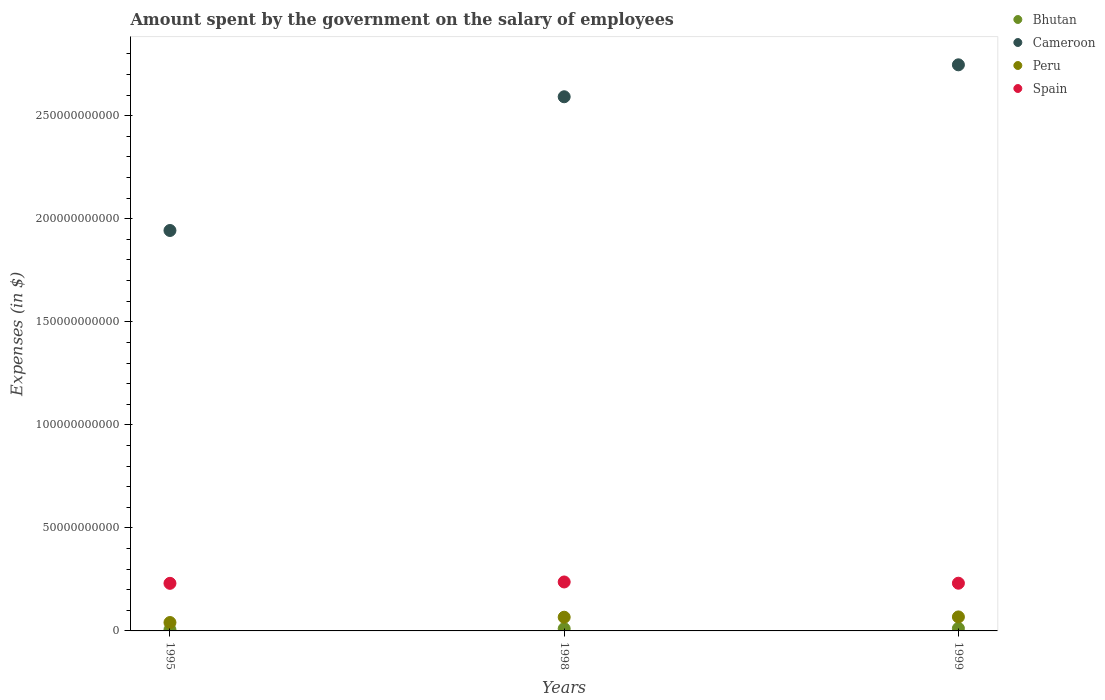Is the number of dotlines equal to the number of legend labels?
Provide a short and direct response. Yes. What is the amount spent on the salary of employees by the government in Cameroon in 1999?
Keep it short and to the point. 2.75e+11. Across all years, what is the maximum amount spent on the salary of employees by the government in Spain?
Ensure brevity in your answer.  2.38e+1. Across all years, what is the minimum amount spent on the salary of employees by the government in Cameroon?
Provide a succinct answer. 1.94e+11. In which year was the amount spent on the salary of employees by the government in Peru maximum?
Provide a succinct answer. 1999. What is the total amount spent on the salary of employees by the government in Bhutan in the graph?
Offer a very short reply. 2.93e+09. What is the difference between the amount spent on the salary of employees by the government in Cameroon in 1995 and that in 1999?
Provide a succinct answer. -8.04e+1. What is the difference between the amount spent on the salary of employees by the government in Peru in 1995 and the amount spent on the salary of employees by the government in Bhutan in 1999?
Provide a short and direct response. 2.85e+09. What is the average amount spent on the salary of employees by the government in Cameroon per year?
Make the answer very short. 2.43e+11. In the year 1998, what is the difference between the amount spent on the salary of employees by the government in Spain and amount spent on the salary of employees by the government in Cameroon?
Provide a short and direct response. -2.35e+11. What is the ratio of the amount spent on the salary of employees by the government in Cameroon in 1995 to that in 1998?
Offer a terse response. 0.75. What is the difference between the highest and the second highest amount spent on the salary of employees by the government in Spain?
Offer a very short reply. 6.02e+08. What is the difference between the highest and the lowest amount spent on the salary of employees by the government in Cameroon?
Offer a terse response. 8.04e+1. In how many years, is the amount spent on the salary of employees by the government in Spain greater than the average amount spent on the salary of employees by the government in Spain taken over all years?
Give a very brief answer. 1. Is the sum of the amount spent on the salary of employees by the government in Cameroon in 1998 and 1999 greater than the maximum amount spent on the salary of employees by the government in Bhutan across all years?
Provide a succinct answer. Yes. Does the amount spent on the salary of employees by the government in Bhutan monotonically increase over the years?
Keep it short and to the point. Yes. Is the amount spent on the salary of employees by the government in Peru strictly greater than the amount spent on the salary of employees by the government in Spain over the years?
Give a very brief answer. No. Is the amount spent on the salary of employees by the government in Bhutan strictly less than the amount spent on the salary of employees by the government in Cameroon over the years?
Offer a very short reply. Yes. How many dotlines are there?
Your answer should be very brief. 4. How many years are there in the graph?
Provide a succinct answer. 3. What is the difference between two consecutive major ticks on the Y-axis?
Offer a terse response. 5.00e+1. Does the graph contain any zero values?
Offer a very short reply. No. Does the graph contain grids?
Your answer should be very brief. No. Where does the legend appear in the graph?
Give a very brief answer. Top right. How many legend labels are there?
Ensure brevity in your answer.  4. What is the title of the graph?
Make the answer very short. Amount spent by the government on the salary of employees. What is the label or title of the Y-axis?
Provide a succinct answer. Expenses (in $). What is the Expenses (in $) in Bhutan in 1995?
Offer a terse response. 6.14e+08. What is the Expenses (in $) in Cameroon in 1995?
Offer a very short reply. 1.94e+11. What is the Expenses (in $) in Peru in 1995?
Your response must be concise. 4.08e+09. What is the Expenses (in $) of Spain in 1995?
Offer a very short reply. 2.31e+1. What is the Expenses (in $) in Bhutan in 1998?
Your answer should be very brief. 1.08e+09. What is the Expenses (in $) of Cameroon in 1998?
Your response must be concise. 2.59e+11. What is the Expenses (in $) in Peru in 1998?
Keep it short and to the point. 6.65e+09. What is the Expenses (in $) of Spain in 1998?
Offer a terse response. 2.38e+1. What is the Expenses (in $) of Bhutan in 1999?
Offer a terse response. 1.23e+09. What is the Expenses (in $) of Cameroon in 1999?
Keep it short and to the point. 2.75e+11. What is the Expenses (in $) of Peru in 1999?
Your answer should be very brief. 6.79e+09. What is the Expenses (in $) of Spain in 1999?
Your response must be concise. 2.32e+1. Across all years, what is the maximum Expenses (in $) of Bhutan?
Make the answer very short. 1.23e+09. Across all years, what is the maximum Expenses (in $) in Cameroon?
Ensure brevity in your answer.  2.75e+11. Across all years, what is the maximum Expenses (in $) of Peru?
Keep it short and to the point. 6.79e+09. Across all years, what is the maximum Expenses (in $) in Spain?
Your answer should be compact. 2.38e+1. Across all years, what is the minimum Expenses (in $) in Bhutan?
Give a very brief answer. 6.14e+08. Across all years, what is the minimum Expenses (in $) of Cameroon?
Ensure brevity in your answer.  1.94e+11. Across all years, what is the minimum Expenses (in $) of Peru?
Ensure brevity in your answer.  4.08e+09. Across all years, what is the minimum Expenses (in $) of Spain?
Offer a very short reply. 2.31e+1. What is the total Expenses (in $) of Bhutan in the graph?
Provide a succinct answer. 2.93e+09. What is the total Expenses (in $) of Cameroon in the graph?
Provide a short and direct response. 7.28e+11. What is the total Expenses (in $) of Peru in the graph?
Offer a very short reply. 1.75e+1. What is the total Expenses (in $) of Spain in the graph?
Offer a terse response. 7.00e+1. What is the difference between the Expenses (in $) of Bhutan in 1995 and that in 1998?
Offer a terse response. -4.71e+08. What is the difference between the Expenses (in $) of Cameroon in 1995 and that in 1998?
Offer a very short reply. -6.49e+1. What is the difference between the Expenses (in $) in Peru in 1995 and that in 1998?
Offer a very short reply. -2.57e+09. What is the difference between the Expenses (in $) of Spain in 1995 and that in 1998?
Offer a terse response. -6.63e+08. What is the difference between the Expenses (in $) of Bhutan in 1995 and that in 1999?
Your answer should be very brief. -6.16e+08. What is the difference between the Expenses (in $) of Cameroon in 1995 and that in 1999?
Make the answer very short. -8.04e+1. What is the difference between the Expenses (in $) in Peru in 1995 and that in 1999?
Keep it short and to the point. -2.72e+09. What is the difference between the Expenses (in $) of Spain in 1995 and that in 1999?
Give a very brief answer. -6.10e+07. What is the difference between the Expenses (in $) of Bhutan in 1998 and that in 1999?
Your answer should be very brief. -1.44e+08. What is the difference between the Expenses (in $) of Cameroon in 1998 and that in 1999?
Ensure brevity in your answer.  -1.55e+1. What is the difference between the Expenses (in $) in Peru in 1998 and that in 1999?
Your response must be concise. -1.46e+08. What is the difference between the Expenses (in $) of Spain in 1998 and that in 1999?
Offer a very short reply. 6.02e+08. What is the difference between the Expenses (in $) in Bhutan in 1995 and the Expenses (in $) in Cameroon in 1998?
Ensure brevity in your answer.  -2.59e+11. What is the difference between the Expenses (in $) in Bhutan in 1995 and the Expenses (in $) in Peru in 1998?
Provide a short and direct response. -6.03e+09. What is the difference between the Expenses (in $) in Bhutan in 1995 and the Expenses (in $) in Spain in 1998?
Give a very brief answer. -2.31e+1. What is the difference between the Expenses (in $) of Cameroon in 1995 and the Expenses (in $) of Peru in 1998?
Your answer should be very brief. 1.88e+11. What is the difference between the Expenses (in $) in Cameroon in 1995 and the Expenses (in $) in Spain in 1998?
Provide a succinct answer. 1.71e+11. What is the difference between the Expenses (in $) in Peru in 1995 and the Expenses (in $) in Spain in 1998?
Your answer should be compact. -1.97e+1. What is the difference between the Expenses (in $) of Bhutan in 1995 and the Expenses (in $) of Cameroon in 1999?
Your answer should be compact. -2.74e+11. What is the difference between the Expenses (in $) of Bhutan in 1995 and the Expenses (in $) of Peru in 1999?
Offer a terse response. -6.18e+09. What is the difference between the Expenses (in $) of Bhutan in 1995 and the Expenses (in $) of Spain in 1999?
Give a very brief answer. -2.25e+1. What is the difference between the Expenses (in $) of Cameroon in 1995 and the Expenses (in $) of Peru in 1999?
Ensure brevity in your answer.  1.88e+11. What is the difference between the Expenses (in $) of Cameroon in 1995 and the Expenses (in $) of Spain in 1999?
Your response must be concise. 1.71e+11. What is the difference between the Expenses (in $) of Peru in 1995 and the Expenses (in $) of Spain in 1999?
Your answer should be compact. -1.91e+1. What is the difference between the Expenses (in $) of Bhutan in 1998 and the Expenses (in $) of Cameroon in 1999?
Ensure brevity in your answer.  -2.74e+11. What is the difference between the Expenses (in $) of Bhutan in 1998 and the Expenses (in $) of Peru in 1999?
Offer a terse response. -5.71e+09. What is the difference between the Expenses (in $) in Bhutan in 1998 and the Expenses (in $) in Spain in 1999?
Give a very brief answer. -2.21e+1. What is the difference between the Expenses (in $) of Cameroon in 1998 and the Expenses (in $) of Peru in 1999?
Your answer should be very brief. 2.52e+11. What is the difference between the Expenses (in $) of Cameroon in 1998 and the Expenses (in $) of Spain in 1999?
Offer a terse response. 2.36e+11. What is the difference between the Expenses (in $) in Peru in 1998 and the Expenses (in $) in Spain in 1999?
Offer a very short reply. -1.65e+1. What is the average Expenses (in $) in Bhutan per year?
Your response must be concise. 9.76e+08. What is the average Expenses (in $) of Cameroon per year?
Make the answer very short. 2.43e+11. What is the average Expenses (in $) in Peru per year?
Keep it short and to the point. 5.84e+09. What is the average Expenses (in $) in Spain per year?
Ensure brevity in your answer.  2.33e+1. In the year 1995, what is the difference between the Expenses (in $) of Bhutan and Expenses (in $) of Cameroon?
Keep it short and to the point. -1.94e+11. In the year 1995, what is the difference between the Expenses (in $) of Bhutan and Expenses (in $) of Peru?
Provide a succinct answer. -3.46e+09. In the year 1995, what is the difference between the Expenses (in $) of Bhutan and Expenses (in $) of Spain?
Keep it short and to the point. -2.25e+1. In the year 1995, what is the difference between the Expenses (in $) in Cameroon and Expenses (in $) in Peru?
Keep it short and to the point. 1.90e+11. In the year 1995, what is the difference between the Expenses (in $) of Cameroon and Expenses (in $) of Spain?
Ensure brevity in your answer.  1.71e+11. In the year 1995, what is the difference between the Expenses (in $) in Peru and Expenses (in $) in Spain?
Offer a very short reply. -1.90e+1. In the year 1998, what is the difference between the Expenses (in $) in Bhutan and Expenses (in $) in Cameroon?
Give a very brief answer. -2.58e+11. In the year 1998, what is the difference between the Expenses (in $) in Bhutan and Expenses (in $) in Peru?
Give a very brief answer. -5.56e+09. In the year 1998, what is the difference between the Expenses (in $) of Bhutan and Expenses (in $) of Spain?
Offer a very short reply. -2.27e+1. In the year 1998, what is the difference between the Expenses (in $) of Cameroon and Expenses (in $) of Peru?
Make the answer very short. 2.53e+11. In the year 1998, what is the difference between the Expenses (in $) in Cameroon and Expenses (in $) in Spain?
Provide a short and direct response. 2.35e+11. In the year 1998, what is the difference between the Expenses (in $) of Peru and Expenses (in $) of Spain?
Your answer should be compact. -1.71e+1. In the year 1999, what is the difference between the Expenses (in $) in Bhutan and Expenses (in $) in Cameroon?
Keep it short and to the point. -2.73e+11. In the year 1999, what is the difference between the Expenses (in $) of Bhutan and Expenses (in $) of Peru?
Keep it short and to the point. -5.56e+09. In the year 1999, what is the difference between the Expenses (in $) of Bhutan and Expenses (in $) of Spain?
Offer a terse response. -2.19e+1. In the year 1999, what is the difference between the Expenses (in $) of Cameroon and Expenses (in $) of Peru?
Offer a very short reply. 2.68e+11. In the year 1999, what is the difference between the Expenses (in $) of Cameroon and Expenses (in $) of Spain?
Make the answer very short. 2.52e+11. In the year 1999, what is the difference between the Expenses (in $) of Peru and Expenses (in $) of Spain?
Offer a terse response. -1.64e+1. What is the ratio of the Expenses (in $) in Bhutan in 1995 to that in 1998?
Ensure brevity in your answer.  0.57. What is the ratio of the Expenses (in $) in Cameroon in 1995 to that in 1998?
Provide a short and direct response. 0.75. What is the ratio of the Expenses (in $) of Peru in 1995 to that in 1998?
Give a very brief answer. 0.61. What is the ratio of the Expenses (in $) of Spain in 1995 to that in 1998?
Keep it short and to the point. 0.97. What is the ratio of the Expenses (in $) in Bhutan in 1995 to that in 1999?
Make the answer very short. 0.5. What is the ratio of the Expenses (in $) in Cameroon in 1995 to that in 1999?
Offer a terse response. 0.71. What is the ratio of the Expenses (in $) in Peru in 1995 to that in 1999?
Offer a very short reply. 0.6. What is the ratio of the Expenses (in $) of Spain in 1995 to that in 1999?
Keep it short and to the point. 1. What is the ratio of the Expenses (in $) of Bhutan in 1998 to that in 1999?
Keep it short and to the point. 0.88. What is the ratio of the Expenses (in $) of Cameroon in 1998 to that in 1999?
Keep it short and to the point. 0.94. What is the ratio of the Expenses (in $) of Peru in 1998 to that in 1999?
Offer a terse response. 0.98. What is the difference between the highest and the second highest Expenses (in $) in Bhutan?
Keep it short and to the point. 1.44e+08. What is the difference between the highest and the second highest Expenses (in $) in Cameroon?
Your answer should be compact. 1.55e+1. What is the difference between the highest and the second highest Expenses (in $) of Peru?
Provide a succinct answer. 1.46e+08. What is the difference between the highest and the second highest Expenses (in $) in Spain?
Make the answer very short. 6.02e+08. What is the difference between the highest and the lowest Expenses (in $) of Bhutan?
Offer a terse response. 6.16e+08. What is the difference between the highest and the lowest Expenses (in $) of Cameroon?
Keep it short and to the point. 8.04e+1. What is the difference between the highest and the lowest Expenses (in $) in Peru?
Your response must be concise. 2.72e+09. What is the difference between the highest and the lowest Expenses (in $) in Spain?
Your answer should be compact. 6.63e+08. 